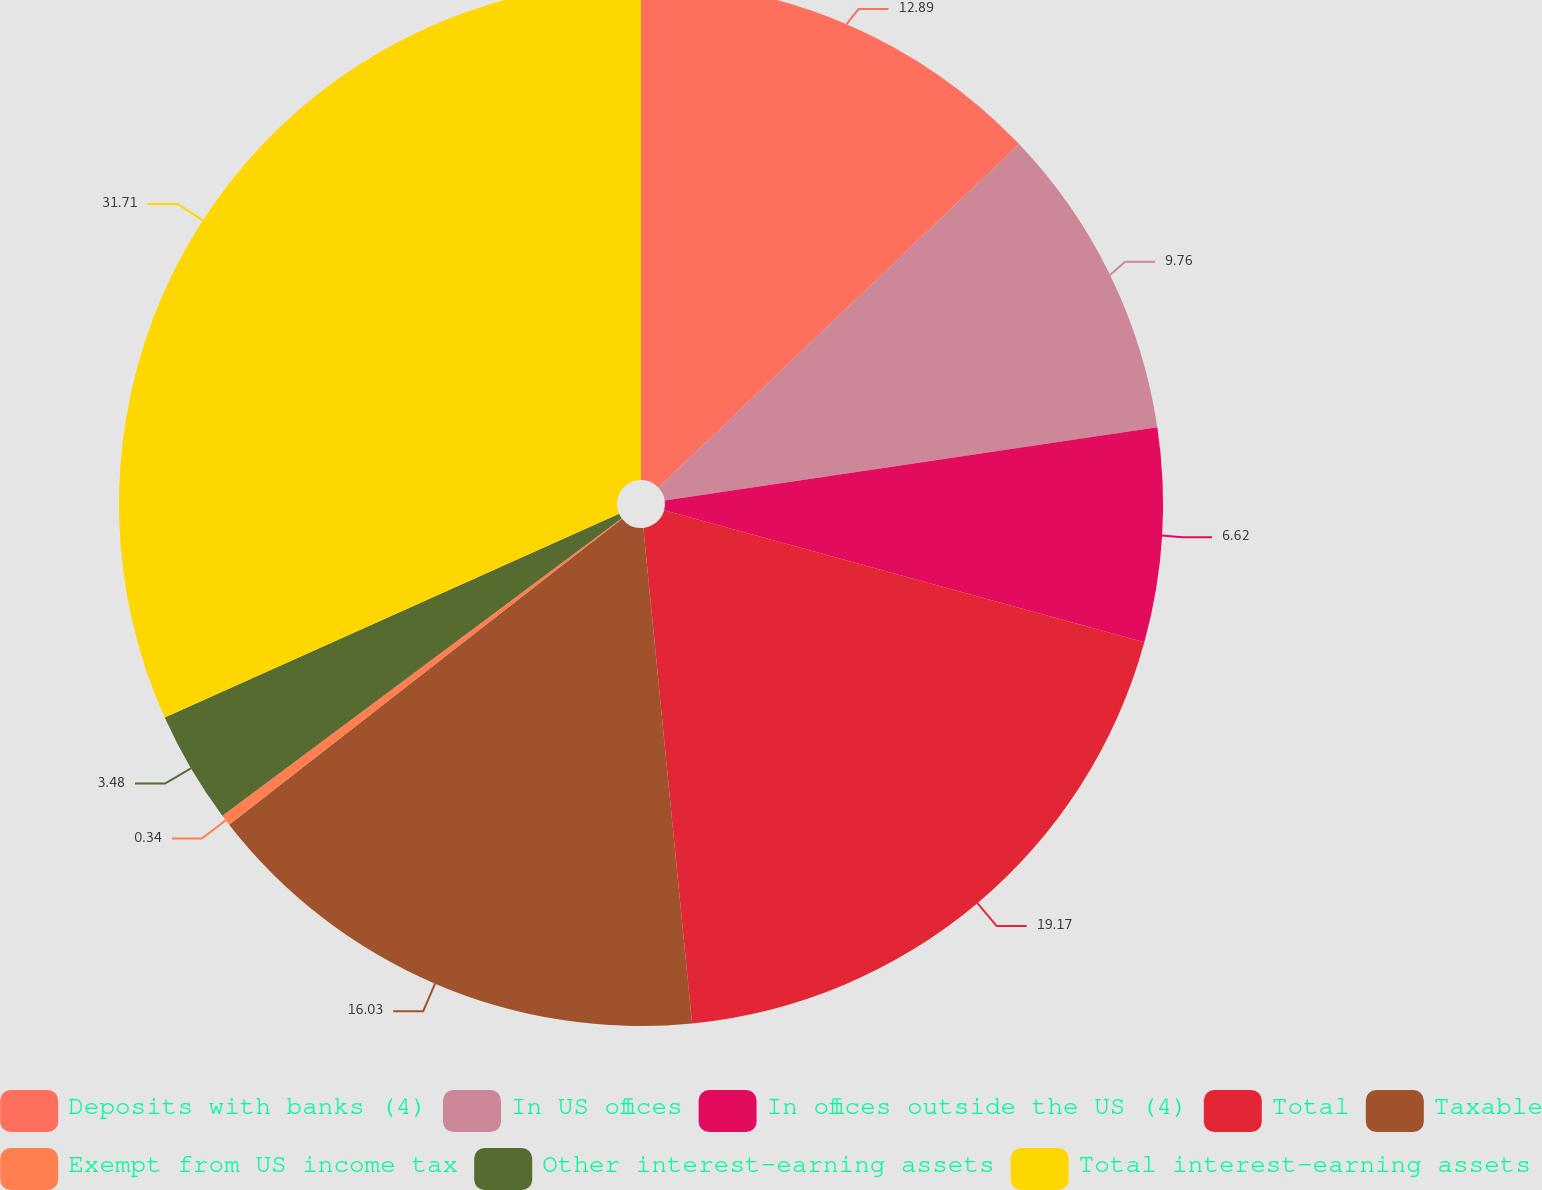Convert chart. <chart><loc_0><loc_0><loc_500><loc_500><pie_chart><fcel>Deposits with banks (4)<fcel>In US offices<fcel>In offices outside the US (4)<fcel>Total<fcel>Taxable<fcel>Exempt from US income tax<fcel>Other interest-earning assets<fcel>Total interest-earning assets<nl><fcel>12.89%<fcel>9.76%<fcel>6.62%<fcel>19.17%<fcel>16.03%<fcel>0.34%<fcel>3.48%<fcel>31.71%<nl></chart> 